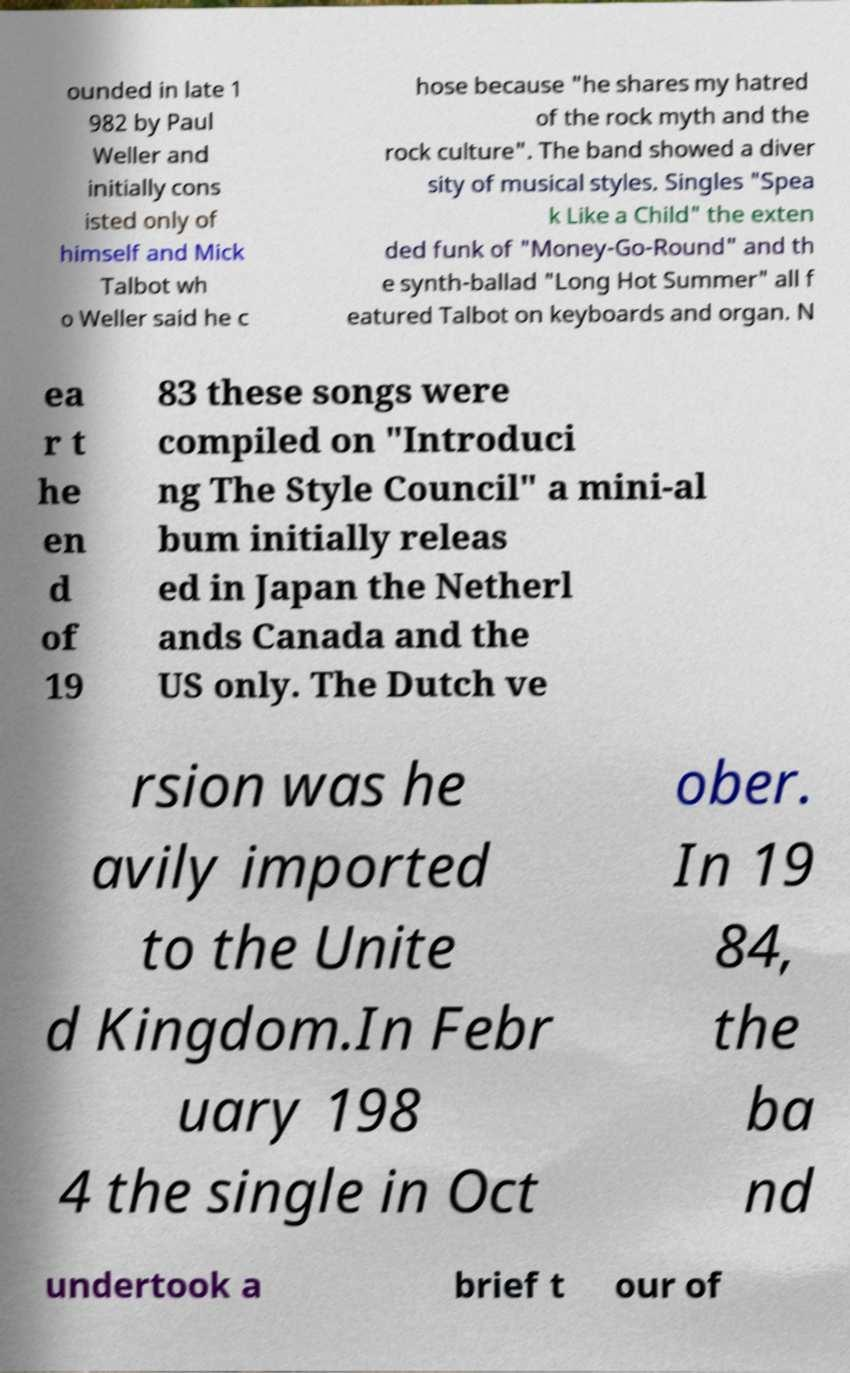Can you read and provide the text displayed in the image?This photo seems to have some interesting text. Can you extract and type it out for me? ounded in late 1 982 by Paul Weller and initially cons isted only of himself and Mick Talbot wh o Weller said he c hose because "he shares my hatred of the rock myth and the rock culture". The band showed a diver sity of musical styles. Singles "Spea k Like a Child" the exten ded funk of "Money-Go-Round" and th e synth-ballad "Long Hot Summer" all f eatured Talbot on keyboards and organ. N ea r t he en d of 19 83 these songs were compiled on "Introduci ng The Style Council" a mini-al bum initially releas ed in Japan the Netherl ands Canada and the US only. The Dutch ve rsion was he avily imported to the Unite d Kingdom.In Febr uary 198 4 the single in Oct ober. In 19 84, the ba nd undertook a brief t our of 